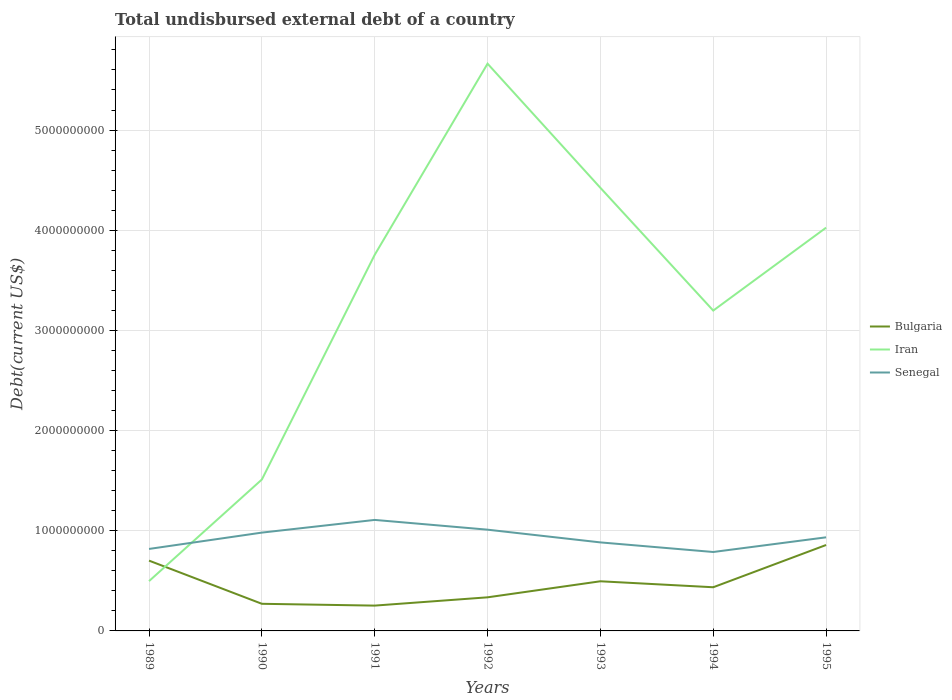Across all years, what is the maximum total undisbursed external debt in Iran?
Your answer should be very brief. 4.97e+08. In which year was the total undisbursed external debt in Iran maximum?
Offer a very short reply. 1989. What is the total total undisbursed external debt in Bulgaria in the graph?
Your response must be concise. -3.62e+08. What is the difference between the highest and the second highest total undisbursed external debt in Bulgaria?
Your answer should be compact. 6.05e+08. How many lines are there?
Your answer should be compact. 3. How many years are there in the graph?
Your answer should be compact. 7. Does the graph contain any zero values?
Make the answer very short. No. How many legend labels are there?
Provide a succinct answer. 3. How are the legend labels stacked?
Make the answer very short. Vertical. What is the title of the graph?
Keep it short and to the point. Total undisbursed external debt of a country. What is the label or title of the Y-axis?
Offer a very short reply. Debt(current US$). What is the Debt(current US$) in Bulgaria in 1989?
Keep it short and to the point. 7.02e+08. What is the Debt(current US$) in Iran in 1989?
Make the answer very short. 4.97e+08. What is the Debt(current US$) in Senegal in 1989?
Your answer should be very brief. 8.18e+08. What is the Debt(current US$) in Bulgaria in 1990?
Your answer should be very brief. 2.71e+08. What is the Debt(current US$) of Iran in 1990?
Provide a short and direct response. 1.51e+09. What is the Debt(current US$) in Senegal in 1990?
Provide a short and direct response. 9.81e+08. What is the Debt(current US$) in Bulgaria in 1991?
Offer a very short reply. 2.53e+08. What is the Debt(current US$) of Iran in 1991?
Make the answer very short. 3.75e+09. What is the Debt(current US$) of Senegal in 1991?
Give a very brief answer. 1.11e+09. What is the Debt(current US$) of Bulgaria in 1992?
Provide a succinct answer. 3.35e+08. What is the Debt(current US$) of Iran in 1992?
Offer a terse response. 5.66e+09. What is the Debt(current US$) of Senegal in 1992?
Provide a succinct answer. 1.01e+09. What is the Debt(current US$) in Bulgaria in 1993?
Ensure brevity in your answer.  4.96e+08. What is the Debt(current US$) of Iran in 1993?
Your answer should be very brief. 4.42e+09. What is the Debt(current US$) in Senegal in 1993?
Your answer should be compact. 8.84e+08. What is the Debt(current US$) of Bulgaria in 1994?
Ensure brevity in your answer.  4.36e+08. What is the Debt(current US$) in Iran in 1994?
Your answer should be very brief. 3.20e+09. What is the Debt(current US$) of Senegal in 1994?
Ensure brevity in your answer.  7.88e+08. What is the Debt(current US$) of Bulgaria in 1995?
Keep it short and to the point. 8.58e+08. What is the Debt(current US$) of Iran in 1995?
Give a very brief answer. 4.03e+09. What is the Debt(current US$) of Senegal in 1995?
Offer a terse response. 9.34e+08. Across all years, what is the maximum Debt(current US$) in Bulgaria?
Offer a terse response. 8.58e+08. Across all years, what is the maximum Debt(current US$) of Iran?
Offer a terse response. 5.66e+09. Across all years, what is the maximum Debt(current US$) of Senegal?
Give a very brief answer. 1.11e+09. Across all years, what is the minimum Debt(current US$) in Bulgaria?
Your response must be concise. 2.53e+08. Across all years, what is the minimum Debt(current US$) of Iran?
Keep it short and to the point. 4.97e+08. Across all years, what is the minimum Debt(current US$) in Senegal?
Ensure brevity in your answer.  7.88e+08. What is the total Debt(current US$) of Bulgaria in the graph?
Offer a very short reply. 3.35e+09. What is the total Debt(current US$) in Iran in the graph?
Ensure brevity in your answer.  2.31e+1. What is the total Debt(current US$) in Senegal in the graph?
Offer a very short reply. 6.52e+09. What is the difference between the Debt(current US$) in Bulgaria in 1989 and that in 1990?
Offer a very short reply. 4.31e+08. What is the difference between the Debt(current US$) in Iran in 1989 and that in 1990?
Offer a terse response. -1.01e+09. What is the difference between the Debt(current US$) of Senegal in 1989 and that in 1990?
Your answer should be compact. -1.63e+08. What is the difference between the Debt(current US$) in Bulgaria in 1989 and that in 1991?
Your answer should be very brief. 4.49e+08. What is the difference between the Debt(current US$) in Iran in 1989 and that in 1991?
Keep it short and to the point. -3.26e+09. What is the difference between the Debt(current US$) in Senegal in 1989 and that in 1991?
Keep it short and to the point. -2.90e+08. What is the difference between the Debt(current US$) in Bulgaria in 1989 and that in 1992?
Give a very brief answer. 3.66e+08. What is the difference between the Debt(current US$) of Iran in 1989 and that in 1992?
Provide a short and direct response. -5.17e+09. What is the difference between the Debt(current US$) in Senegal in 1989 and that in 1992?
Make the answer very short. -1.92e+08. What is the difference between the Debt(current US$) in Bulgaria in 1989 and that in 1993?
Ensure brevity in your answer.  2.06e+08. What is the difference between the Debt(current US$) in Iran in 1989 and that in 1993?
Offer a very short reply. -3.93e+09. What is the difference between the Debt(current US$) in Senegal in 1989 and that in 1993?
Provide a short and direct response. -6.52e+07. What is the difference between the Debt(current US$) in Bulgaria in 1989 and that in 1994?
Provide a short and direct response. 2.66e+08. What is the difference between the Debt(current US$) of Iran in 1989 and that in 1994?
Your answer should be compact. -2.70e+09. What is the difference between the Debt(current US$) of Senegal in 1989 and that in 1994?
Offer a terse response. 3.05e+07. What is the difference between the Debt(current US$) of Bulgaria in 1989 and that in 1995?
Provide a succinct answer. -1.56e+08. What is the difference between the Debt(current US$) in Iran in 1989 and that in 1995?
Provide a short and direct response. -3.53e+09. What is the difference between the Debt(current US$) in Senegal in 1989 and that in 1995?
Provide a short and direct response. -1.16e+08. What is the difference between the Debt(current US$) in Bulgaria in 1990 and that in 1991?
Make the answer very short. 1.81e+07. What is the difference between the Debt(current US$) of Iran in 1990 and that in 1991?
Give a very brief answer. -2.24e+09. What is the difference between the Debt(current US$) of Senegal in 1990 and that in 1991?
Make the answer very short. -1.27e+08. What is the difference between the Debt(current US$) in Bulgaria in 1990 and that in 1992?
Provide a succinct answer. -6.46e+07. What is the difference between the Debt(current US$) of Iran in 1990 and that in 1992?
Offer a very short reply. -4.15e+09. What is the difference between the Debt(current US$) in Senegal in 1990 and that in 1992?
Give a very brief answer. -2.93e+07. What is the difference between the Debt(current US$) of Bulgaria in 1990 and that in 1993?
Provide a succinct answer. -2.25e+08. What is the difference between the Debt(current US$) of Iran in 1990 and that in 1993?
Give a very brief answer. -2.91e+09. What is the difference between the Debt(current US$) of Senegal in 1990 and that in 1993?
Your answer should be compact. 9.78e+07. What is the difference between the Debt(current US$) in Bulgaria in 1990 and that in 1994?
Your answer should be very brief. -1.65e+08. What is the difference between the Debt(current US$) of Iran in 1990 and that in 1994?
Give a very brief answer. -1.69e+09. What is the difference between the Debt(current US$) in Senegal in 1990 and that in 1994?
Make the answer very short. 1.94e+08. What is the difference between the Debt(current US$) of Bulgaria in 1990 and that in 1995?
Give a very brief answer. -5.87e+08. What is the difference between the Debt(current US$) in Iran in 1990 and that in 1995?
Keep it short and to the point. -2.51e+09. What is the difference between the Debt(current US$) in Senegal in 1990 and that in 1995?
Ensure brevity in your answer.  4.71e+07. What is the difference between the Debt(current US$) of Bulgaria in 1991 and that in 1992?
Offer a very short reply. -8.27e+07. What is the difference between the Debt(current US$) in Iran in 1991 and that in 1992?
Give a very brief answer. -1.91e+09. What is the difference between the Debt(current US$) of Senegal in 1991 and that in 1992?
Offer a very short reply. 9.74e+07. What is the difference between the Debt(current US$) in Bulgaria in 1991 and that in 1993?
Ensure brevity in your answer.  -2.43e+08. What is the difference between the Debt(current US$) of Iran in 1991 and that in 1993?
Make the answer very short. -6.69e+08. What is the difference between the Debt(current US$) of Senegal in 1991 and that in 1993?
Offer a terse response. 2.24e+08. What is the difference between the Debt(current US$) of Bulgaria in 1991 and that in 1994?
Make the answer very short. -1.83e+08. What is the difference between the Debt(current US$) in Iran in 1991 and that in 1994?
Ensure brevity in your answer.  5.57e+08. What is the difference between the Debt(current US$) in Senegal in 1991 and that in 1994?
Make the answer very short. 3.20e+08. What is the difference between the Debt(current US$) in Bulgaria in 1991 and that in 1995?
Give a very brief answer. -6.05e+08. What is the difference between the Debt(current US$) in Iran in 1991 and that in 1995?
Offer a terse response. -2.71e+08. What is the difference between the Debt(current US$) of Senegal in 1991 and that in 1995?
Your response must be concise. 1.74e+08. What is the difference between the Debt(current US$) of Bulgaria in 1992 and that in 1993?
Your response must be concise. -1.60e+08. What is the difference between the Debt(current US$) of Iran in 1992 and that in 1993?
Provide a succinct answer. 1.24e+09. What is the difference between the Debt(current US$) in Senegal in 1992 and that in 1993?
Offer a very short reply. 1.27e+08. What is the difference between the Debt(current US$) in Bulgaria in 1992 and that in 1994?
Keep it short and to the point. -1.00e+08. What is the difference between the Debt(current US$) of Iran in 1992 and that in 1994?
Provide a succinct answer. 2.46e+09. What is the difference between the Debt(current US$) of Senegal in 1992 and that in 1994?
Keep it short and to the point. 2.23e+08. What is the difference between the Debt(current US$) in Bulgaria in 1992 and that in 1995?
Keep it short and to the point. -5.22e+08. What is the difference between the Debt(current US$) of Iran in 1992 and that in 1995?
Your answer should be very brief. 1.64e+09. What is the difference between the Debt(current US$) in Senegal in 1992 and that in 1995?
Keep it short and to the point. 7.63e+07. What is the difference between the Debt(current US$) in Bulgaria in 1993 and that in 1994?
Give a very brief answer. 5.97e+07. What is the difference between the Debt(current US$) of Iran in 1993 and that in 1994?
Offer a very short reply. 1.23e+09. What is the difference between the Debt(current US$) in Senegal in 1993 and that in 1994?
Your response must be concise. 9.58e+07. What is the difference between the Debt(current US$) in Bulgaria in 1993 and that in 1995?
Provide a succinct answer. -3.62e+08. What is the difference between the Debt(current US$) in Iran in 1993 and that in 1995?
Offer a terse response. 3.98e+08. What is the difference between the Debt(current US$) in Senegal in 1993 and that in 1995?
Offer a terse response. -5.07e+07. What is the difference between the Debt(current US$) of Bulgaria in 1994 and that in 1995?
Provide a succinct answer. -4.22e+08. What is the difference between the Debt(current US$) in Iran in 1994 and that in 1995?
Ensure brevity in your answer.  -8.28e+08. What is the difference between the Debt(current US$) of Senegal in 1994 and that in 1995?
Keep it short and to the point. -1.46e+08. What is the difference between the Debt(current US$) of Bulgaria in 1989 and the Debt(current US$) of Iran in 1990?
Your response must be concise. -8.10e+08. What is the difference between the Debt(current US$) of Bulgaria in 1989 and the Debt(current US$) of Senegal in 1990?
Offer a very short reply. -2.80e+08. What is the difference between the Debt(current US$) in Iran in 1989 and the Debt(current US$) in Senegal in 1990?
Your answer should be compact. -4.84e+08. What is the difference between the Debt(current US$) in Bulgaria in 1989 and the Debt(current US$) in Iran in 1991?
Your answer should be compact. -3.05e+09. What is the difference between the Debt(current US$) of Bulgaria in 1989 and the Debt(current US$) of Senegal in 1991?
Provide a short and direct response. -4.06e+08. What is the difference between the Debt(current US$) of Iran in 1989 and the Debt(current US$) of Senegal in 1991?
Your response must be concise. -6.11e+08. What is the difference between the Debt(current US$) of Bulgaria in 1989 and the Debt(current US$) of Iran in 1992?
Offer a very short reply. -4.96e+09. What is the difference between the Debt(current US$) of Bulgaria in 1989 and the Debt(current US$) of Senegal in 1992?
Your response must be concise. -3.09e+08. What is the difference between the Debt(current US$) in Iran in 1989 and the Debt(current US$) in Senegal in 1992?
Offer a terse response. -5.14e+08. What is the difference between the Debt(current US$) in Bulgaria in 1989 and the Debt(current US$) in Iran in 1993?
Your answer should be very brief. -3.72e+09. What is the difference between the Debt(current US$) of Bulgaria in 1989 and the Debt(current US$) of Senegal in 1993?
Provide a short and direct response. -1.82e+08. What is the difference between the Debt(current US$) of Iran in 1989 and the Debt(current US$) of Senegal in 1993?
Your answer should be compact. -3.86e+08. What is the difference between the Debt(current US$) of Bulgaria in 1989 and the Debt(current US$) of Iran in 1994?
Your response must be concise. -2.50e+09. What is the difference between the Debt(current US$) of Bulgaria in 1989 and the Debt(current US$) of Senegal in 1994?
Your answer should be very brief. -8.61e+07. What is the difference between the Debt(current US$) of Iran in 1989 and the Debt(current US$) of Senegal in 1994?
Give a very brief answer. -2.91e+08. What is the difference between the Debt(current US$) in Bulgaria in 1989 and the Debt(current US$) in Iran in 1995?
Provide a short and direct response. -3.32e+09. What is the difference between the Debt(current US$) in Bulgaria in 1989 and the Debt(current US$) in Senegal in 1995?
Provide a succinct answer. -2.33e+08. What is the difference between the Debt(current US$) in Iran in 1989 and the Debt(current US$) in Senegal in 1995?
Offer a terse response. -4.37e+08. What is the difference between the Debt(current US$) of Bulgaria in 1990 and the Debt(current US$) of Iran in 1991?
Give a very brief answer. -3.48e+09. What is the difference between the Debt(current US$) in Bulgaria in 1990 and the Debt(current US$) in Senegal in 1991?
Provide a succinct answer. -8.37e+08. What is the difference between the Debt(current US$) of Iran in 1990 and the Debt(current US$) of Senegal in 1991?
Keep it short and to the point. 4.03e+08. What is the difference between the Debt(current US$) of Bulgaria in 1990 and the Debt(current US$) of Iran in 1992?
Provide a short and direct response. -5.39e+09. What is the difference between the Debt(current US$) in Bulgaria in 1990 and the Debt(current US$) in Senegal in 1992?
Provide a short and direct response. -7.40e+08. What is the difference between the Debt(current US$) in Iran in 1990 and the Debt(current US$) in Senegal in 1992?
Keep it short and to the point. 5.01e+08. What is the difference between the Debt(current US$) in Bulgaria in 1990 and the Debt(current US$) in Iran in 1993?
Provide a short and direct response. -4.15e+09. What is the difference between the Debt(current US$) in Bulgaria in 1990 and the Debt(current US$) in Senegal in 1993?
Make the answer very short. -6.13e+08. What is the difference between the Debt(current US$) in Iran in 1990 and the Debt(current US$) in Senegal in 1993?
Make the answer very short. 6.28e+08. What is the difference between the Debt(current US$) in Bulgaria in 1990 and the Debt(current US$) in Iran in 1994?
Offer a very short reply. -2.93e+09. What is the difference between the Debt(current US$) of Bulgaria in 1990 and the Debt(current US$) of Senegal in 1994?
Ensure brevity in your answer.  -5.17e+08. What is the difference between the Debt(current US$) of Iran in 1990 and the Debt(current US$) of Senegal in 1994?
Offer a terse response. 7.24e+08. What is the difference between the Debt(current US$) of Bulgaria in 1990 and the Debt(current US$) of Iran in 1995?
Offer a terse response. -3.75e+09. What is the difference between the Debt(current US$) in Bulgaria in 1990 and the Debt(current US$) in Senegal in 1995?
Keep it short and to the point. -6.64e+08. What is the difference between the Debt(current US$) of Iran in 1990 and the Debt(current US$) of Senegal in 1995?
Keep it short and to the point. 5.77e+08. What is the difference between the Debt(current US$) of Bulgaria in 1991 and the Debt(current US$) of Iran in 1992?
Offer a very short reply. -5.41e+09. What is the difference between the Debt(current US$) of Bulgaria in 1991 and the Debt(current US$) of Senegal in 1992?
Ensure brevity in your answer.  -7.58e+08. What is the difference between the Debt(current US$) of Iran in 1991 and the Debt(current US$) of Senegal in 1992?
Your response must be concise. 2.74e+09. What is the difference between the Debt(current US$) of Bulgaria in 1991 and the Debt(current US$) of Iran in 1993?
Offer a terse response. -4.17e+09. What is the difference between the Debt(current US$) in Bulgaria in 1991 and the Debt(current US$) in Senegal in 1993?
Offer a terse response. -6.31e+08. What is the difference between the Debt(current US$) in Iran in 1991 and the Debt(current US$) in Senegal in 1993?
Ensure brevity in your answer.  2.87e+09. What is the difference between the Debt(current US$) of Bulgaria in 1991 and the Debt(current US$) of Iran in 1994?
Your answer should be compact. -2.95e+09. What is the difference between the Debt(current US$) in Bulgaria in 1991 and the Debt(current US$) in Senegal in 1994?
Offer a terse response. -5.35e+08. What is the difference between the Debt(current US$) in Iran in 1991 and the Debt(current US$) in Senegal in 1994?
Your answer should be very brief. 2.97e+09. What is the difference between the Debt(current US$) of Bulgaria in 1991 and the Debt(current US$) of Iran in 1995?
Make the answer very short. -3.77e+09. What is the difference between the Debt(current US$) of Bulgaria in 1991 and the Debt(current US$) of Senegal in 1995?
Provide a succinct answer. -6.82e+08. What is the difference between the Debt(current US$) in Iran in 1991 and the Debt(current US$) in Senegal in 1995?
Offer a very short reply. 2.82e+09. What is the difference between the Debt(current US$) of Bulgaria in 1992 and the Debt(current US$) of Iran in 1993?
Make the answer very short. -4.09e+09. What is the difference between the Debt(current US$) in Bulgaria in 1992 and the Debt(current US$) in Senegal in 1993?
Offer a very short reply. -5.48e+08. What is the difference between the Debt(current US$) of Iran in 1992 and the Debt(current US$) of Senegal in 1993?
Ensure brevity in your answer.  4.78e+09. What is the difference between the Debt(current US$) in Bulgaria in 1992 and the Debt(current US$) in Iran in 1994?
Your response must be concise. -2.86e+09. What is the difference between the Debt(current US$) of Bulgaria in 1992 and the Debt(current US$) of Senegal in 1994?
Provide a short and direct response. -4.52e+08. What is the difference between the Debt(current US$) of Iran in 1992 and the Debt(current US$) of Senegal in 1994?
Your response must be concise. 4.87e+09. What is the difference between the Debt(current US$) of Bulgaria in 1992 and the Debt(current US$) of Iran in 1995?
Your answer should be compact. -3.69e+09. What is the difference between the Debt(current US$) of Bulgaria in 1992 and the Debt(current US$) of Senegal in 1995?
Ensure brevity in your answer.  -5.99e+08. What is the difference between the Debt(current US$) in Iran in 1992 and the Debt(current US$) in Senegal in 1995?
Give a very brief answer. 4.73e+09. What is the difference between the Debt(current US$) of Bulgaria in 1993 and the Debt(current US$) of Iran in 1994?
Your response must be concise. -2.70e+09. What is the difference between the Debt(current US$) of Bulgaria in 1993 and the Debt(current US$) of Senegal in 1994?
Ensure brevity in your answer.  -2.92e+08. What is the difference between the Debt(current US$) in Iran in 1993 and the Debt(current US$) in Senegal in 1994?
Your response must be concise. 3.64e+09. What is the difference between the Debt(current US$) in Bulgaria in 1993 and the Debt(current US$) in Iran in 1995?
Give a very brief answer. -3.53e+09. What is the difference between the Debt(current US$) in Bulgaria in 1993 and the Debt(current US$) in Senegal in 1995?
Your response must be concise. -4.39e+08. What is the difference between the Debt(current US$) in Iran in 1993 and the Debt(current US$) in Senegal in 1995?
Offer a terse response. 3.49e+09. What is the difference between the Debt(current US$) of Bulgaria in 1994 and the Debt(current US$) of Iran in 1995?
Ensure brevity in your answer.  -3.59e+09. What is the difference between the Debt(current US$) in Bulgaria in 1994 and the Debt(current US$) in Senegal in 1995?
Ensure brevity in your answer.  -4.98e+08. What is the difference between the Debt(current US$) of Iran in 1994 and the Debt(current US$) of Senegal in 1995?
Ensure brevity in your answer.  2.26e+09. What is the average Debt(current US$) in Bulgaria per year?
Offer a very short reply. 4.79e+08. What is the average Debt(current US$) in Iran per year?
Your answer should be very brief. 3.30e+09. What is the average Debt(current US$) of Senegal per year?
Give a very brief answer. 9.32e+08. In the year 1989, what is the difference between the Debt(current US$) of Bulgaria and Debt(current US$) of Iran?
Your answer should be compact. 2.05e+08. In the year 1989, what is the difference between the Debt(current US$) of Bulgaria and Debt(current US$) of Senegal?
Offer a very short reply. -1.17e+08. In the year 1989, what is the difference between the Debt(current US$) of Iran and Debt(current US$) of Senegal?
Your response must be concise. -3.21e+08. In the year 1990, what is the difference between the Debt(current US$) of Bulgaria and Debt(current US$) of Iran?
Make the answer very short. -1.24e+09. In the year 1990, what is the difference between the Debt(current US$) in Bulgaria and Debt(current US$) in Senegal?
Ensure brevity in your answer.  -7.11e+08. In the year 1990, what is the difference between the Debt(current US$) of Iran and Debt(current US$) of Senegal?
Provide a succinct answer. 5.30e+08. In the year 1991, what is the difference between the Debt(current US$) of Bulgaria and Debt(current US$) of Iran?
Your answer should be very brief. -3.50e+09. In the year 1991, what is the difference between the Debt(current US$) in Bulgaria and Debt(current US$) in Senegal?
Offer a terse response. -8.55e+08. In the year 1991, what is the difference between the Debt(current US$) of Iran and Debt(current US$) of Senegal?
Your response must be concise. 2.65e+09. In the year 1992, what is the difference between the Debt(current US$) in Bulgaria and Debt(current US$) in Iran?
Keep it short and to the point. -5.33e+09. In the year 1992, what is the difference between the Debt(current US$) of Bulgaria and Debt(current US$) of Senegal?
Provide a short and direct response. -6.75e+08. In the year 1992, what is the difference between the Debt(current US$) in Iran and Debt(current US$) in Senegal?
Offer a terse response. 4.65e+09. In the year 1993, what is the difference between the Debt(current US$) of Bulgaria and Debt(current US$) of Iran?
Provide a succinct answer. -3.93e+09. In the year 1993, what is the difference between the Debt(current US$) of Bulgaria and Debt(current US$) of Senegal?
Your answer should be compact. -3.88e+08. In the year 1993, what is the difference between the Debt(current US$) in Iran and Debt(current US$) in Senegal?
Provide a short and direct response. 3.54e+09. In the year 1994, what is the difference between the Debt(current US$) in Bulgaria and Debt(current US$) in Iran?
Make the answer very short. -2.76e+09. In the year 1994, what is the difference between the Debt(current US$) in Bulgaria and Debt(current US$) in Senegal?
Your answer should be compact. -3.52e+08. In the year 1994, what is the difference between the Debt(current US$) of Iran and Debt(current US$) of Senegal?
Offer a very short reply. 2.41e+09. In the year 1995, what is the difference between the Debt(current US$) in Bulgaria and Debt(current US$) in Iran?
Your response must be concise. -3.17e+09. In the year 1995, what is the difference between the Debt(current US$) of Bulgaria and Debt(current US$) of Senegal?
Your answer should be compact. -7.66e+07. In the year 1995, what is the difference between the Debt(current US$) of Iran and Debt(current US$) of Senegal?
Your response must be concise. 3.09e+09. What is the ratio of the Debt(current US$) of Bulgaria in 1989 to that in 1990?
Ensure brevity in your answer.  2.59. What is the ratio of the Debt(current US$) in Iran in 1989 to that in 1990?
Provide a succinct answer. 0.33. What is the ratio of the Debt(current US$) of Senegal in 1989 to that in 1990?
Your response must be concise. 0.83. What is the ratio of the Debt(current US$) in Bulgaria in 1989 to that in 1991?
Your response must be concise. 2.78. What is the ratio of the Debt(current US$) of Iran in 1989 to that in 1991?
Provide a succinct answer. 0.13. What is the ratio of the Debt(current US$) in Senegal in 1989 to that in 1991?
Offer a very short reply. 0.74. What is the ratio of the Debt(current US$) of Bulgaria in 1989 to that in 1992?
Provide a succinct answer. 2.09. What is the ratio of the Debt(current US$) of Iran in 1989 to that in 1992?
Keep it short and to the point. 0.09. What is the ratio of the Debt(current US$) of Senegal in 1989 to that in 1992?
Provide a succinct answer. 0.81. What is the ratio of the Debt(current US$) of Bulgaria in 1989 to that in 1993?
Your answer should be very brief. 1.42. What is the ratio of the Debt(current US$) of Iran in 1989 to that in 1993?
Offer a very short reply. 0.11. What is the ratio of the Debt(current US$) of Senegal in 1989 to that in 1993?
Your answer should be very brief. 0.93. What is the ratio of the Debt(current US$) of Bulgaria in 1989 to that in 1994?
Ensure brevity in your answer.  1.61. What is the ratio of the Debt(current US$) of Iran in 1989 to that in 1994?
Your answer should be very brief. 0.16. What is the ratio of the Debt(current US$) in Senegal in 1989 to that in 1994?
Offer a very short reply. 1.04. What is the ratio of the Debt(current US$) of Bulgaria in 1989 to that in 1995?
Ensure brevity in your answer.  0.82. What is the ratio of the Debt(current US$) in Iran in 1989 to that in 1995?
Give a very brief answer. 0.12. What is the ratio of the Debt(current US$) in Senegal in 1989 to that in 1995?
Ensure brevity in your answer.  0.88. What is the ratio of the Debt(current US$) in Bulgaria in 1990 to that in 1991?
Keep it short and to the point. 1.07. What is the ratio of the Debt(current US$) in Iran in 1990 to that in 1991?
Provide a succinct answer. 0.4. What is the ratio of the Debt(current US$) in Senegal in 1990 to that in 1991?
Offer a very short reply. 0.89. What is the ratio of the Debt(current US$) in Bulgaria in 1990 to that in 1992?
Provide a short and direct response. 0.81. What is the ratio of the Debt(current US$) of Iran in 1990 to that in 1992?
Your answer should be very brief. 0.27. What is the ratio of the Debt(current US$) of Senegal in 1990 to that in 1992?
Keep it short and to the point. 0.97. What is the ratio of the Debt(current US$) of Bulgaria in 1990 to that in 1993?
Keep it short and to the point. 0.55. What is the ratio of the Debt(current US$) in Iran in 1990 to that in 1993?
Offer a terse response. 0.34. What is the ratio of the Debt(current US$) of Senegal in 1990 to that in 1993?
Keep it short and to the point. 1.11. What is the ratio of the Debt(current US$) in Bulgaria in 1990 to that in 1994?
Make the answer very short. 0.62. What is the ratio of the Debt(current US$) in Iran in 1990 to that in 1994?
Your answer should be compact. 0.47. What is the ratio of the Debt(current US$) of Senegal in 1990 to that in 1994?
Keep it short and to the point. 1.25. What is the ratio of the Debt(current US$) of Bulgaria in 1990 to that in 1995?
Ensure brevity in your answer.  0.32. What is the ratio of the Debt(current US$) of Iran in 1990 to that in 1995?
Your answer should be very brief. 0.38. What is the ratio of the Debt(current US$) of Senegal in 1990 to that in 1995?
Give a very brief answer. 1.05. What is the ratio of the Debt(current US$) in Bulgaria in 1991 to that in 1992?
Your answer should be very brief. 0.75. What is the ratio of the Debt(current US$) in Iran in 1991 to that in 1992?
Your answer should be very brief. 0.66. What is the ratio of the Debt(current US$) of Senegal in 1991 to that in 1992?
Give a very brief answer. 1.1. What is the ratio of the Debt(current US$) in Bulgaria in 1991 to that in 1993?
Provide a short and direct response. 0.51. What is the ratio of the Debt(current US$) of Iran in 1991 to that in 1993?
Your response must be concise. 0.85. What is the ratio of the Debt(current US$) in Senegal in 1991 to that in 1993?
Your answer should be compact. 1.25. What is the ratio of the Debt(current US$) of Bulgaria in 1991 to that in 1994?
Offer a terse response. 0.58. What is the ratio of the Debt(current US$) in Iran in 1991 to that in 1994?
Your response must be concise. 1.17. What is the ratio of the Debt(current US$) of Senegal in 1991 to that in 1994?
Your response must be concise. 1.41. What is the ratio of the Debt(current US$) in Bulgaria in 1991 to that in 1995?
Provide a short and direct response. 0.29. What is the ratio of the Debt(current US$) in Iran in 1991 to that in 1995?
Your answer should be very brief. 0.93. What is the ratio of the Debt(current US$) in Senegal in 1991 to that in 1995?
Keep it short and to the point. 1.19. What is the ratio of the Debt(current US$) of Bulgaria in 1992 to that in 1993?
Your response must be concise. 0.68. What is the ratio of the Debt(current US$) in Iran in 1992 to that in 1993?
Make the answer very short. 1.28. What is the ratio of the Debt(current US$) of Senegal in 1992 to that in 1993?
Keep it short and to the point. 1.14. What is the ratio of the Debt(current US$) in Bulgaria in 1992 to that in 1994?
Your answer should be compact. 0.77. What is the ratio of the Debt(current US$) in Iran in 1992 to that in 1994?
Your response must be concise. 1.77. What is the ratio of the Debt(current US$) in Senegal in 1992 to that in 1994?
Your response must be concise. 1.28. What is the ratio of the Debt(current US$) of Bulgaria in 1992 to that in 1995?
Provide a short and direct response. 0.39. What is the ratio of the Debt(current US$) in Iran in 1992 to that in 1995?
Make the answer very short. 1.41. What is the ratio of the Debt(current US$) of Senegal in 1992 to that in 1995?
Provide a succinct answer. 1.08. What is the ratio of the Debt(current US$) of Bulgaria in 1993 to that in 1994?
Offer a very short reply. 1.14. What is the ratio of the Debt(current US$) in Iran in 1993 to that in 1994?
Provide a succinct answer. 1.38. What is the ratio of the Debt(current US$) in Senegal in 1993 to that in 1994?
Provide a succinct answer. 1.12. What is the ratio of the Debt(current US$) in Bulgaria in 1993 to that in 1995?
Offer a very short reply. 0.58. What is the ratio of the Debt(current US$) of Iran in 1993 to that in 1995?
Provide a succinct answer. 1.1. What is the ratio of the Debt(current US$) in Senegal in 1993 to that in 1995?
Your answer should be compact. 0.95. What is the ratio of the Debt(current US$) of Bulgaria in 1994 to that in 1995?
Ensure brevity in your answer.  0.51. What is the ratio of the Debt(current US$) in Iran in 1994 to that in 1995?
Make the answer very short. 0.79. What is the ratio of the Debt(current US$) in Senegal in 1994 to that in 1995?
Keep it short and to the point. 0.84. What is the difference between the highest and the second highest Debt(current US$) in Bulgaria?
Ensure brevity in your answer.  1.56e+08. What is the difference between the highest and the second highest Debt(current US$) in Iran?
Your answer should be very brief. 1.24e+09. What is the difference between the highest and the second highest Debt(current US$) in Senegal?
Offer a very short reply. 9.74e+07. What is the difference between the highest and the lowest Debt(current US$) in Bulgaria?
Provide a short and direct response. 6.05e+08. What is the difference between the highest and the lowest Debt(current US$) of Iran?
Make the answer very short. 5.17e+09. What is the difference between the highest and the lowest Debt(current US$) of Senegal?
Provide a short and direct response. 3.20e+08. 